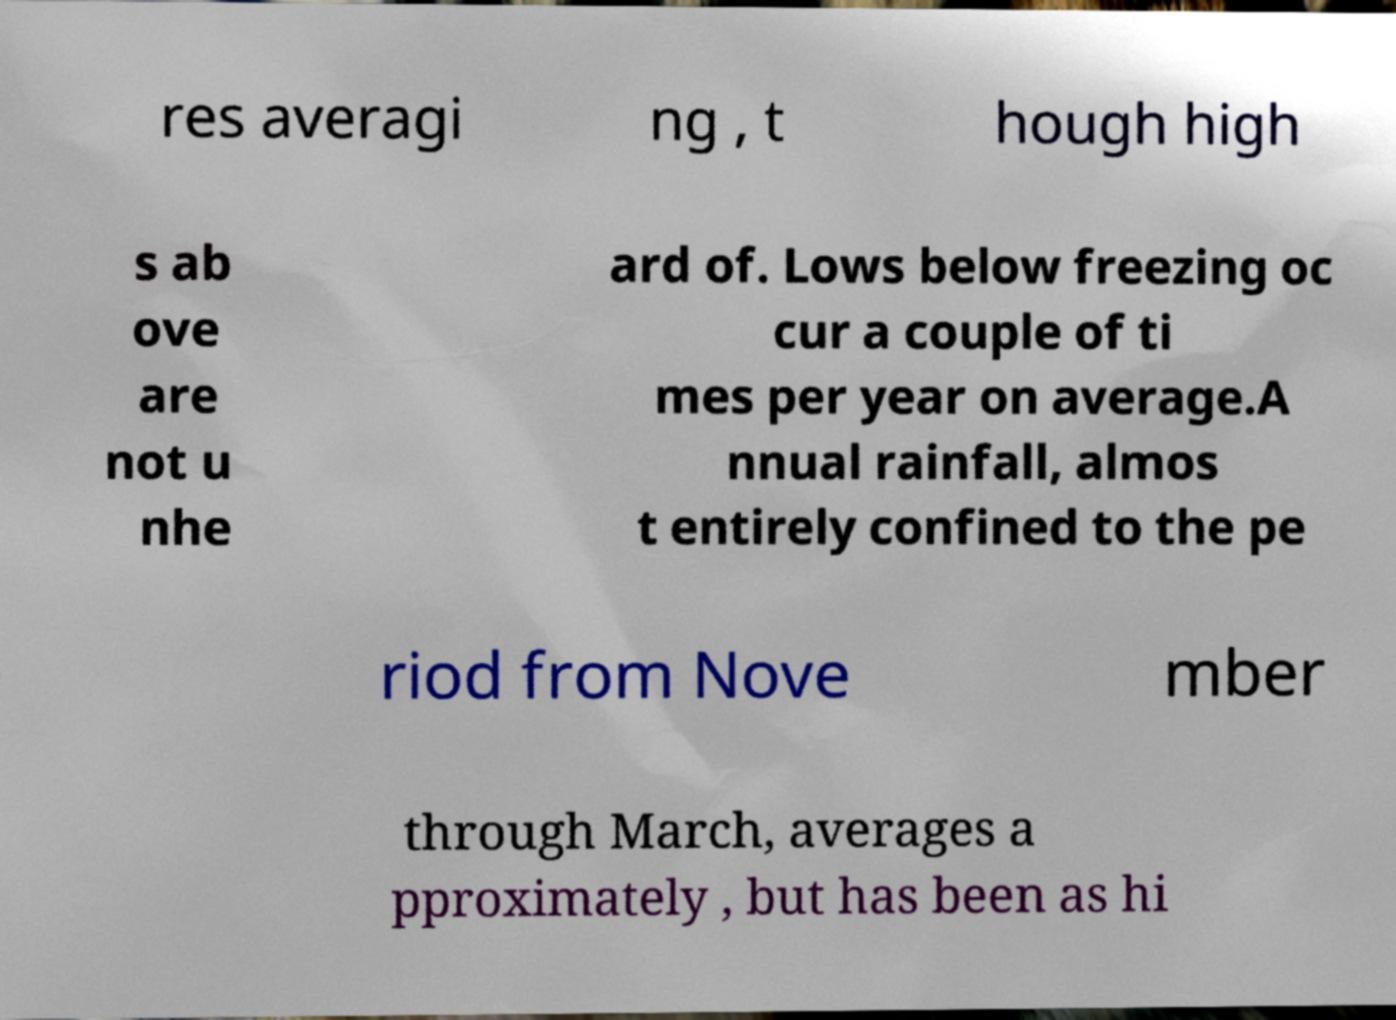For documentation purposes, I need the text within this image transcribed. Could you provide that? res averagi ng , t hough high s ab ove are not u nhe ard of. Lows below freezing oc cur a couple of ti mes per year on average.A nnual rainfall, almos t entirely confined to the pe riod from Nove mber through March, averages a pproximately , but has been as hi 